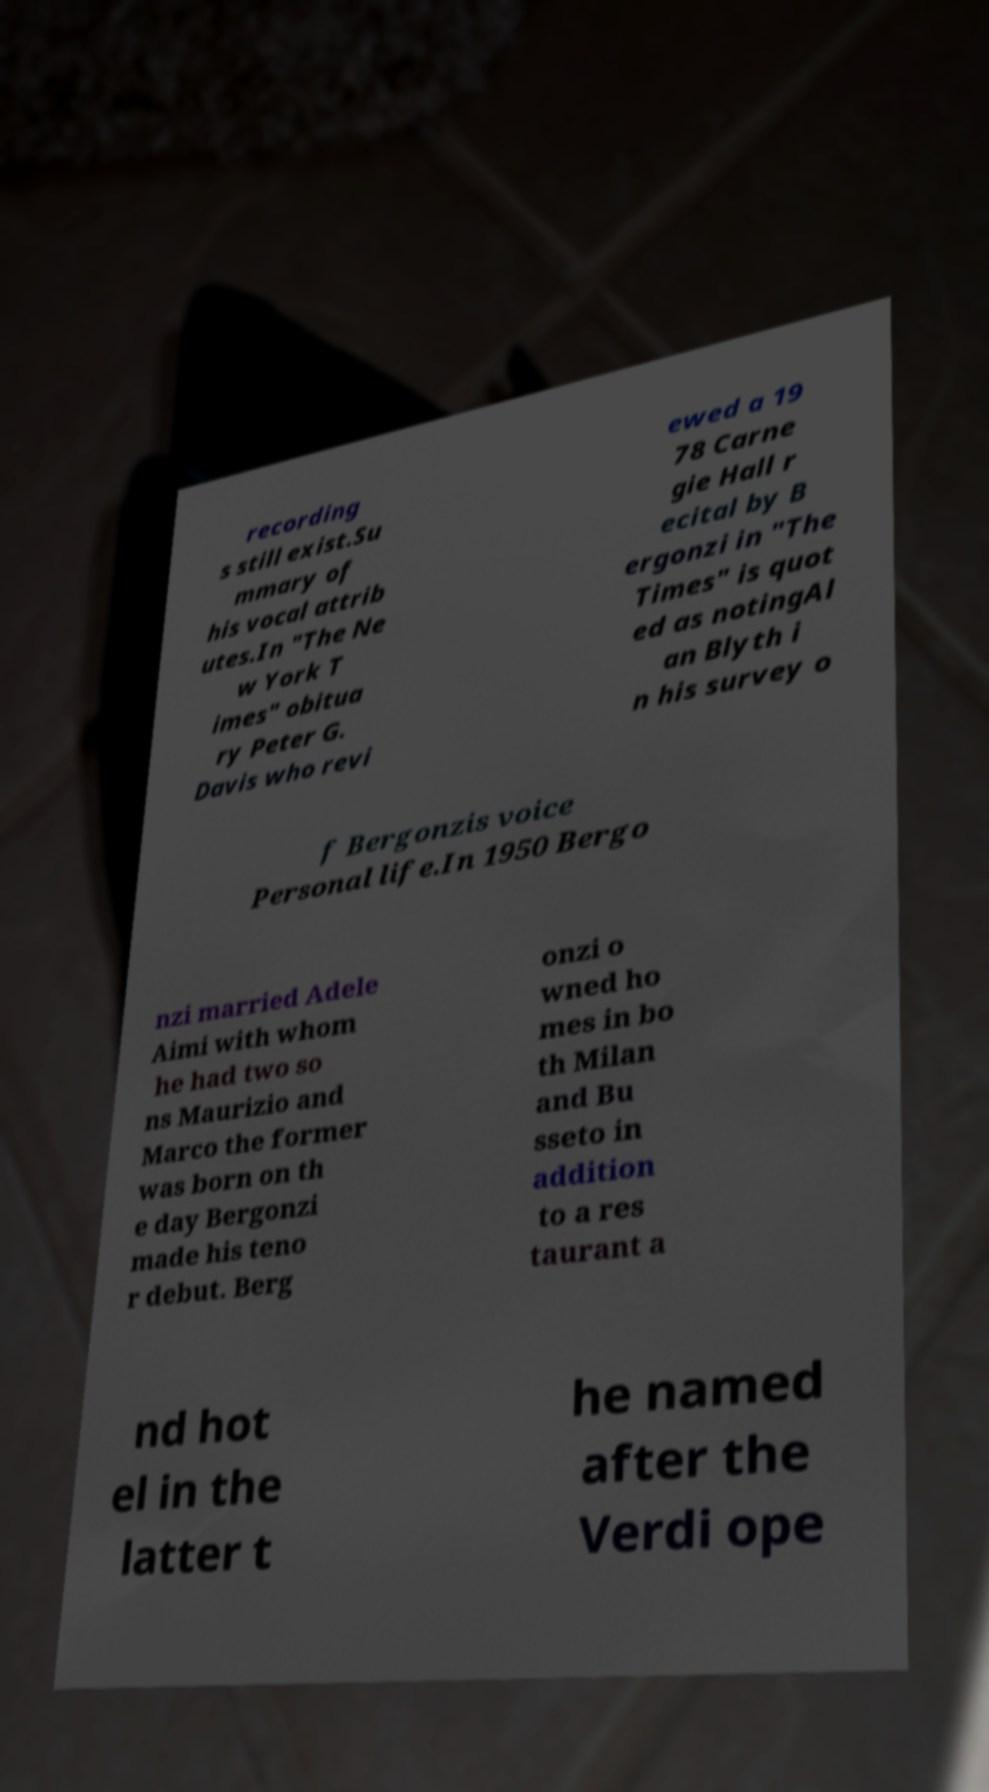Please read and relay the text visible in this image. What does it say? recording s still exist.Su mmary of his vocal attrib utes.In "The Ne w York T imes" obitua ry Peter G. Davis who revi ewed a 19 78 Carne gie Hall r ecital by B ergonzi in "The Times" is quot ed as notingAl an Blyth i n his survey o f Bergonzis voice Personal life.In 1950 Bergo nzi married Adele Aimi with whom he had two so ns Maurizio and Marco the former was born on th e day Bergonzi made his teno r debut. Berg onzi o wned ho mes in bo th Milan and Bu sseto in addition to a res taurant a nd hot el in the latter t he named after the Verdi ope 